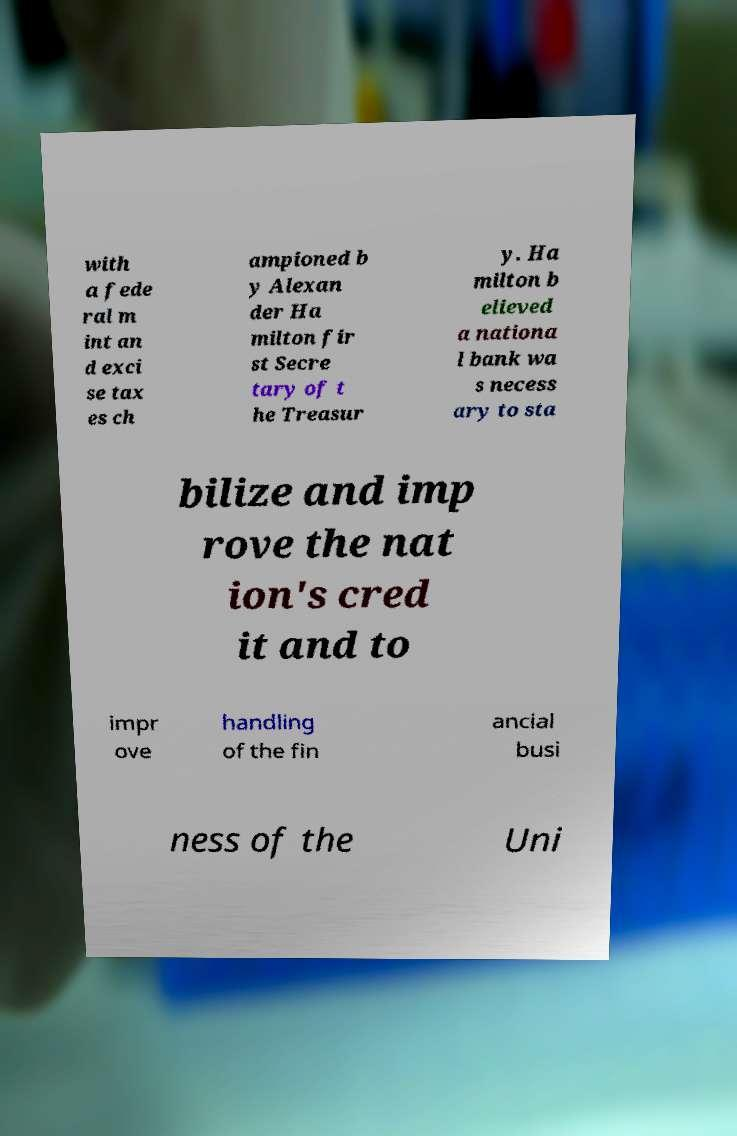Can you accurately transcribe the text from the provided image for me? with a fede ral m int an d exci se tax es ch ampioned b y Alexan der Ha milton fir st Secre tary of t he Treasur y. Ha milton b elieved a nationa l bank wa s necess ary to sta bilize and imp rove the nat ion's cred it and to impr ove handling of the fin ancial busi ness of the Uni 